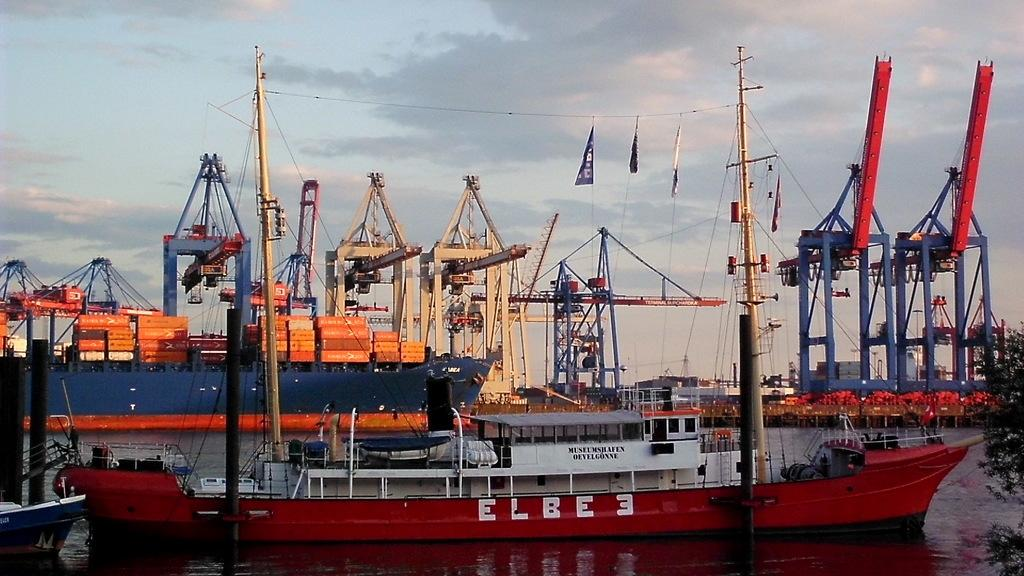What is at the bottom of the image? There is water at the bottom of the image. What can be seen above the water in the image? There are ships above the water. Where is the tree located in the image? The tree is in the bottom right corner of the image. What type of farm can be seen in the image? There is no farm present in the image. How many apples are hanging from the tree in the image? There are no apples visible in the image, as it only shows a tree in the bottom right corner. 